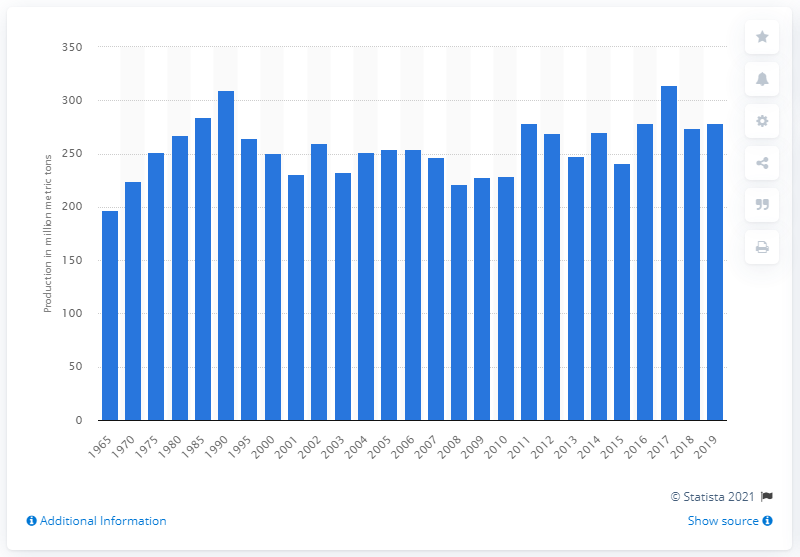How does the production trend relate to concerns about health and sugar consumption? Although there's been a rise in production over the years visible in the chart, public health campaigns and increasing awareness of the effects of sugar on health have led to a greater demand for reduced-sugar products. This has influenced some countries to adopt measures to lower sugar consumption, which can indirectly affect sugar beet production. Producers may need to adjust to these changes by diversifying crops or seeking innovations to meet evolving consumer preferences. 